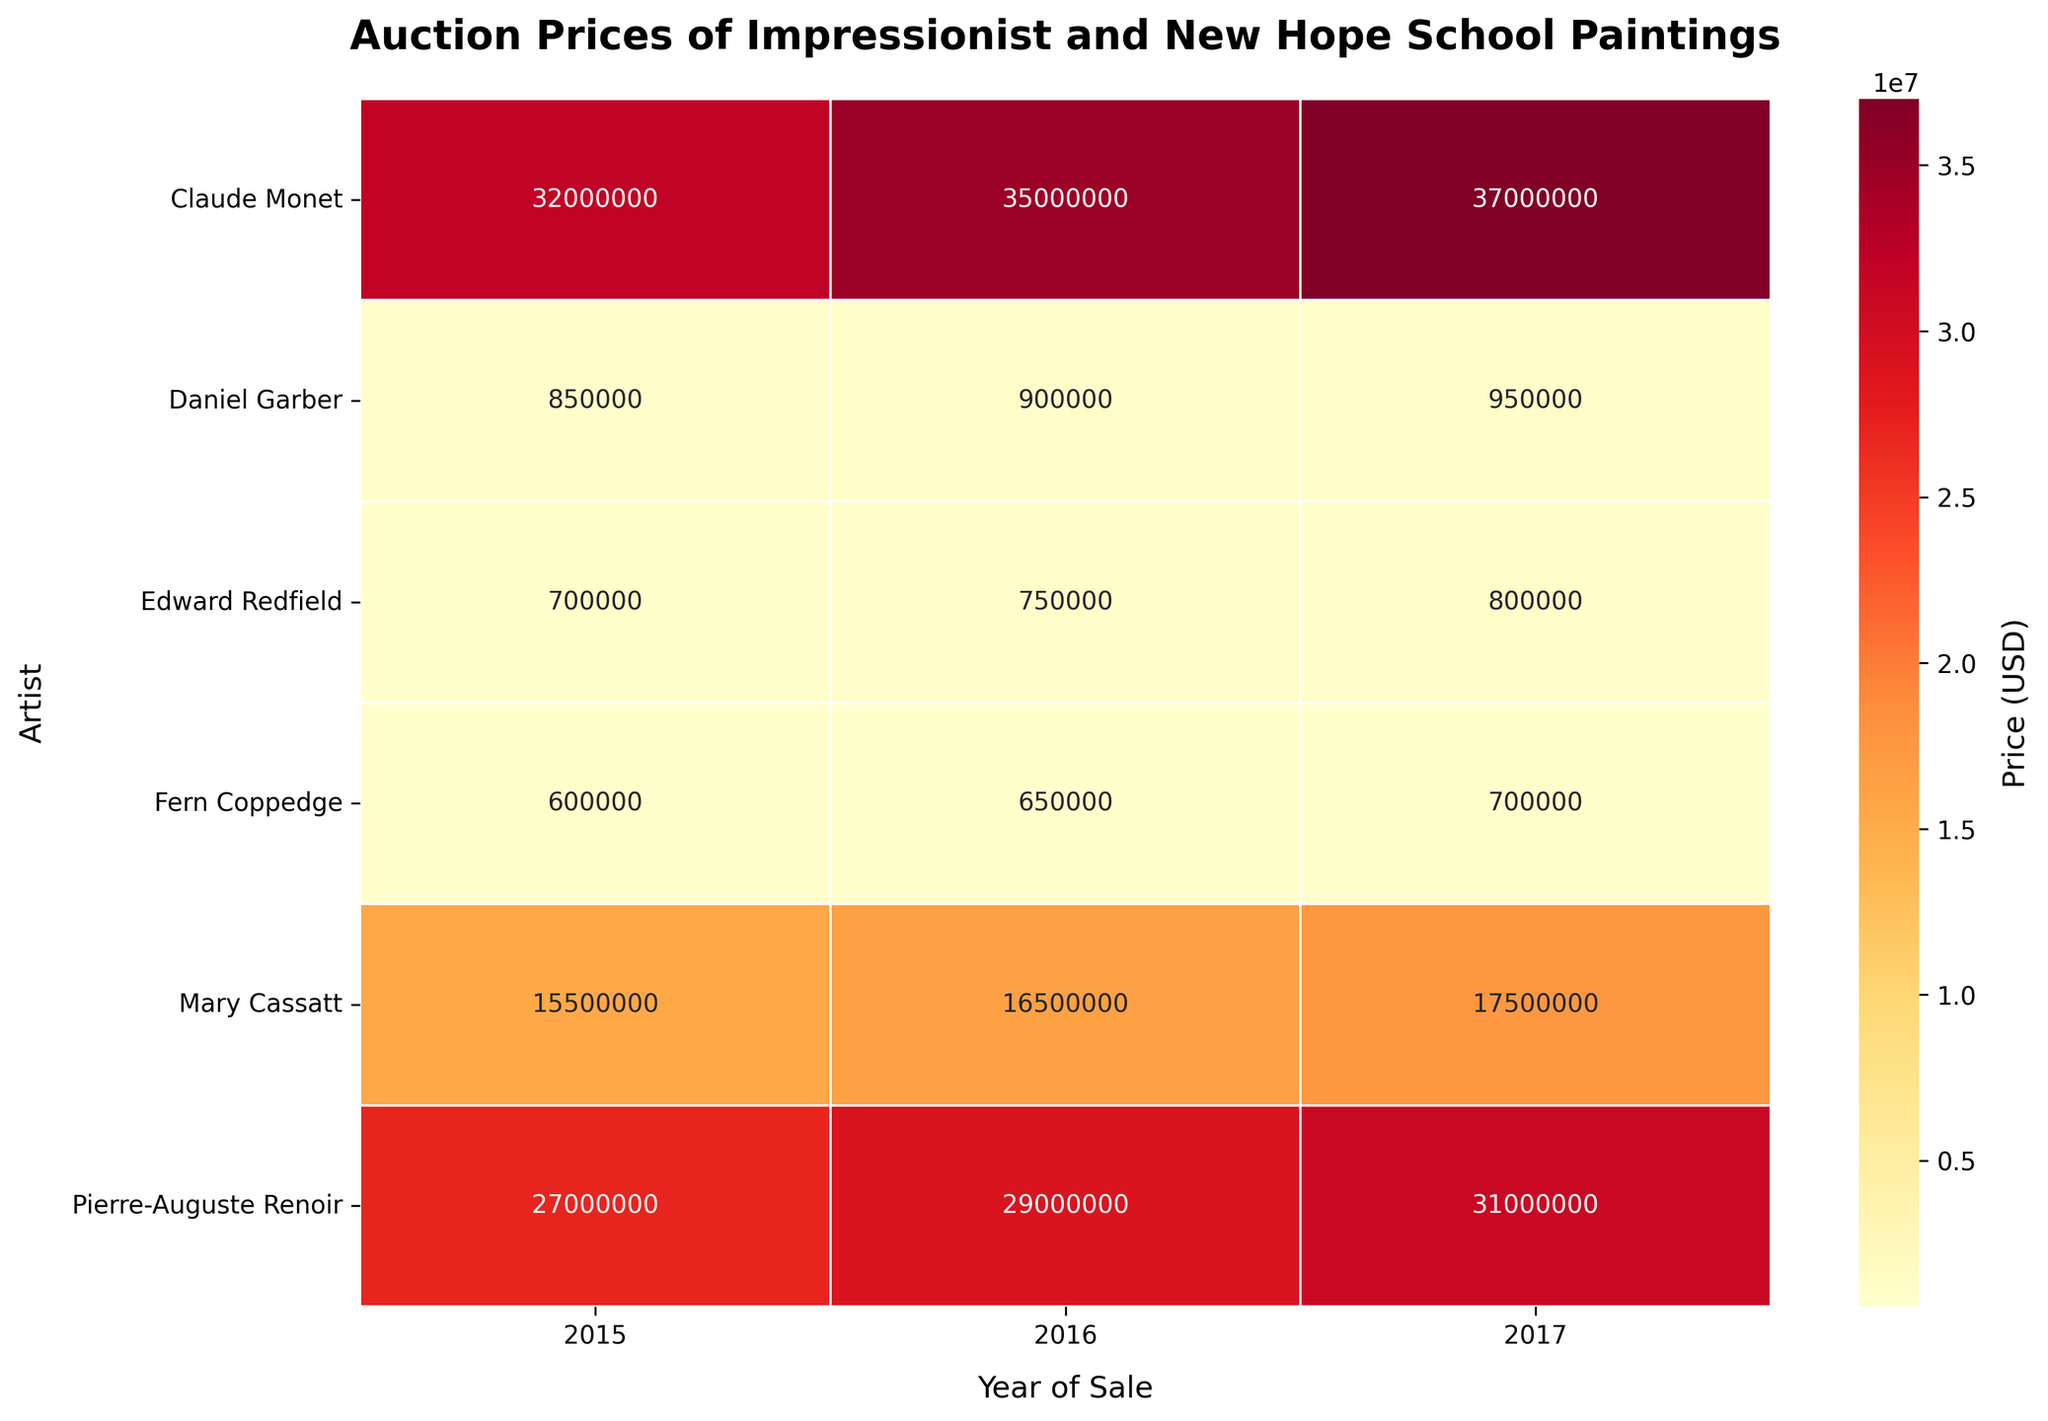What is the title of the heatmap? The title is typically found at the top of the figure and usually describes what information the visualization is showing. In this heatmap, we can see the text at the top of the image.
Answer: Auction Prices of Impressionist and New Hope School Paintings Which artist had the highest auction price in 2017? To find the highest auction price in a specific year, scan the column labeled 2017 and identify the maximum value. Here, the highest value is in the row for Claude Monet.
Answer: Claude Monet What was the average auction price of Claude Monet's paintings over the three years? List the prices for Claude Monet in 2015, 2016, and 2017, then calculate the average of these values: (32000000 + 35000000 + 37000000)/3 = 34666666.67
Answer: 34666667 How did Fern Coppedge's auction prices change from 2015 to 2017? Look at the prices for Fern Coppedge in 2015, 2016, and 2017. Note the increase each year: 600000 in 2015, 650000 in 2016, and 700000 in 2017. The trend indicates an increase each year.
Answer: Increased Which artist had the lowest average auction price over the three years? Calculate the average price for each artist over the three years by summing their prices and dividing by three. Compare these averages and find the smallest one. Edward Redfield had the averages (700000 + 750000 + 800000)/3 = 750000, which is the lowest among all artists.
Answer: Edward Redfield Compare the auction prices of Pierre-Auguste Renoir in 2015 and Mary Cassatt in 2017. Which one is higher? Look at Pierre-Auguste Renoir’s auction price in 2015 (27000000) and Mary Cassatt’s in 2017 (17500000). Compare these two values to see which is greater.
Answer: Pierre-Auguste Renoir in 2015 What's the difference in auction price between Mary Cassatt and Daniel Garber in 2016? Identify the prices for Mary Cassatt (16500000) and Daniel Garber (900000) in 2016. Subtract the smaller value from the larger one: 16500000 - 900000 = 15600000.
Answer: 15600000 In which year did Edward Redfield have his highest auction price? Review the auction prices for Edward Redfield over the three years. Compare 700000 in 2015, 750000 in 2016, and 800000 in 2017. The highest value is found in 2017.
Answer: 2017 What is the general trend of auction prices for Daniel Garber from 2015 to 2017? Observe the auction prices for Daniel Garber across 2015, 2016, and 2017. They are 850000, 900000, and 950000 respectively, showing a steady increase each year.
Answer: Increasing 